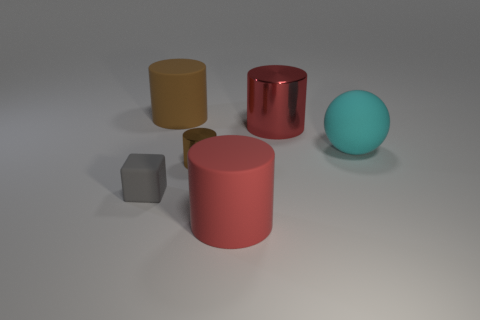Can you tell me the position of the red shiny object relative to the other objects? The red shiny object, which is a large cylinder, is centrally placed among the other objects. To its immediate left is a yellow cylinder and to its right are a cube and a blue sphere. The blue sphere is the furthest to the right, while the cube is placed in front of the red cylinder, slightly to the right. 